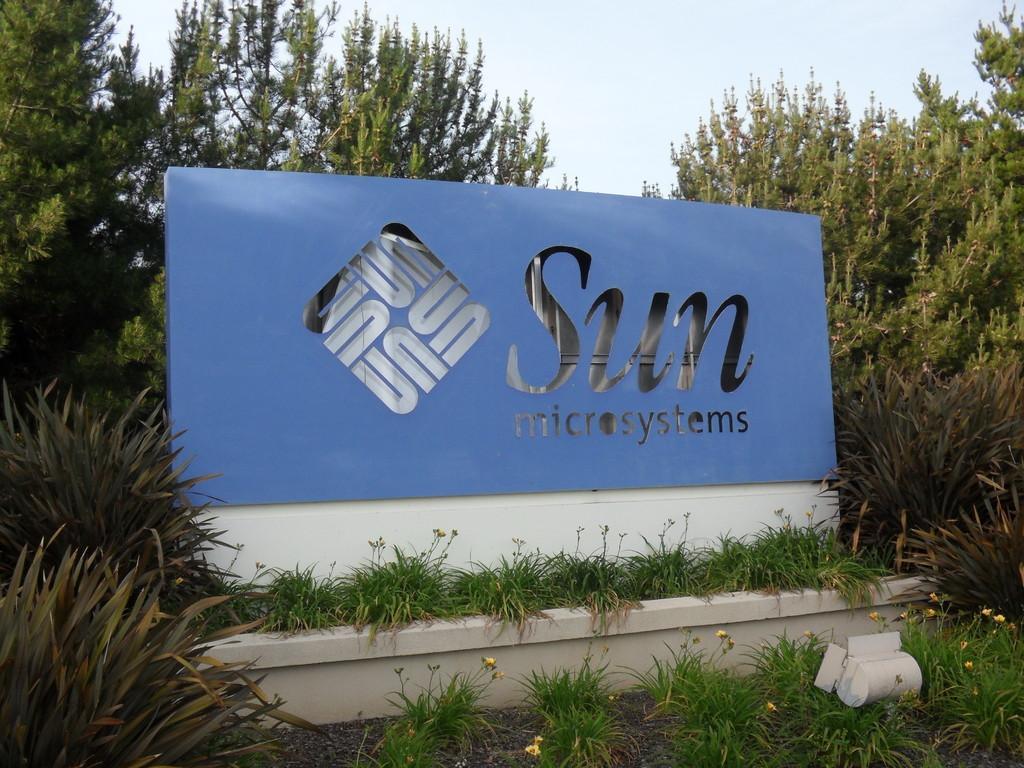Could you give a brief overview of what you see in this image? This picture is clicked outside. In the center we can see a blue color object on which we can see the text and we can see the green grass, plants, trees, sky and some other objects. 